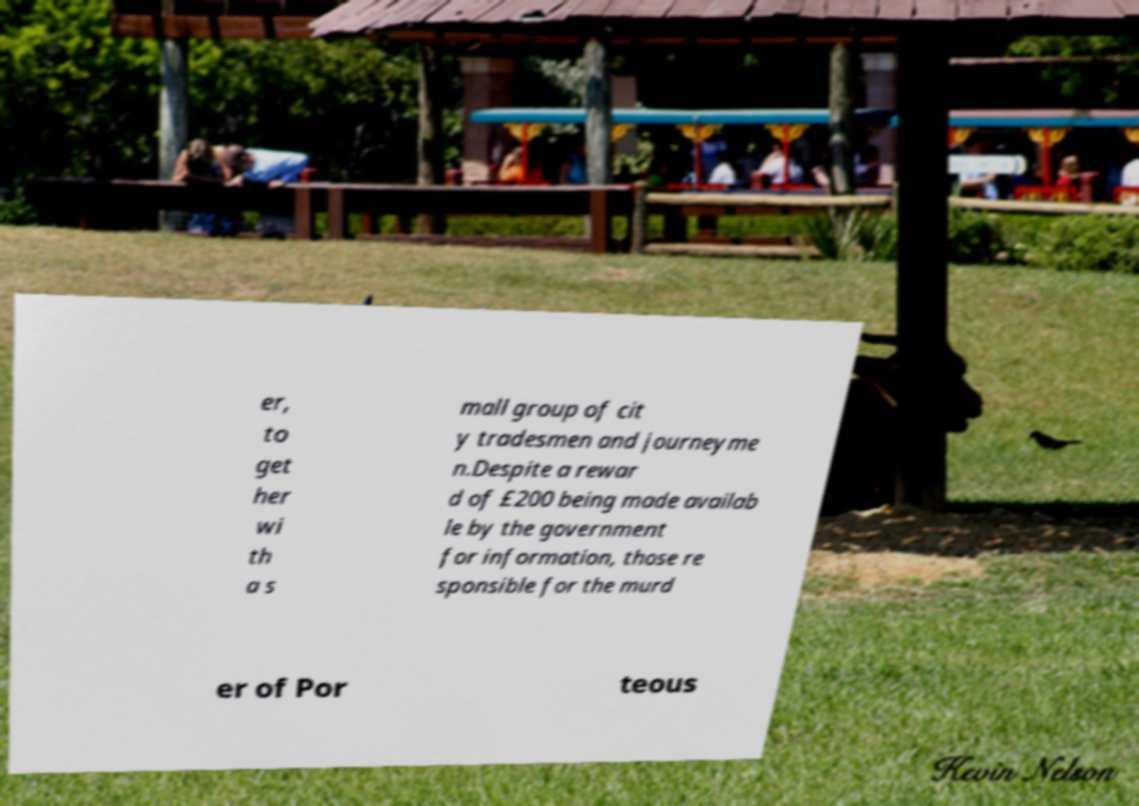Could you assist in decoding the text presented in this image and type it out clearly? er, to get her wi th a s mall group of cit y tradesmen and journeyme n.Despite a rewar d of £200 being made availab le by the government for information, those re sponsible for the murd er of Por teous 